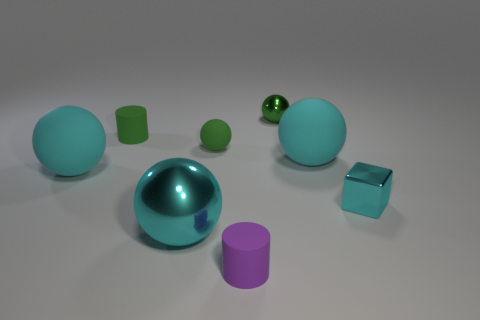Subtract all tiny metal spheres. How many spheres are left? 4 Add 1 small cyan objects. How many objects exist? 9 Subtract all cubes. How many objects are left? 7 Add 5 matte cylinders. How many matte cylinders are left? 7 Add 4 small brown metal spheres. How many small brown metal spheres exist? 4 Subtract all purple cylinders. How many cylinders are left? 1 Subtract 0 purple balls. How many objects are left? 8 Subtract 1 cubes. How many cubes are left? 0 Subtract all purple cylinders. Subtract all green spheres. How many cylinders are left? 1 Subtract all brown balls. How many purple blocks are left? 0 